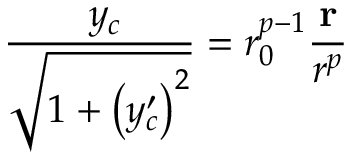<formula> <loc_0><loc_0><loc_500><loc_500>\frac { { \nabla } y _ { c } } { \sqrt { 1 + \left ( y _ { c } ^ { \prime } \right ) ^ { 2 } } } = r _ { 0 } ^ { p - 1 } \frac { r } { r ^ { p } }</formula> 